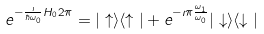<formula> <loc_0><loc_0><loc_500><loc_500>e ^ { - \frac { \imath } { \hbar { \omega } _ { 0 } } H _ { 0 } 2 \pi } = | \uparrow \rangle \langle \uparrow | + e ^ { - \imath \pi \frac { \omega _ { 1 } } { \omega _ { 0 } } } | \downarrow \rangle \langle \downarrow |</formula> 